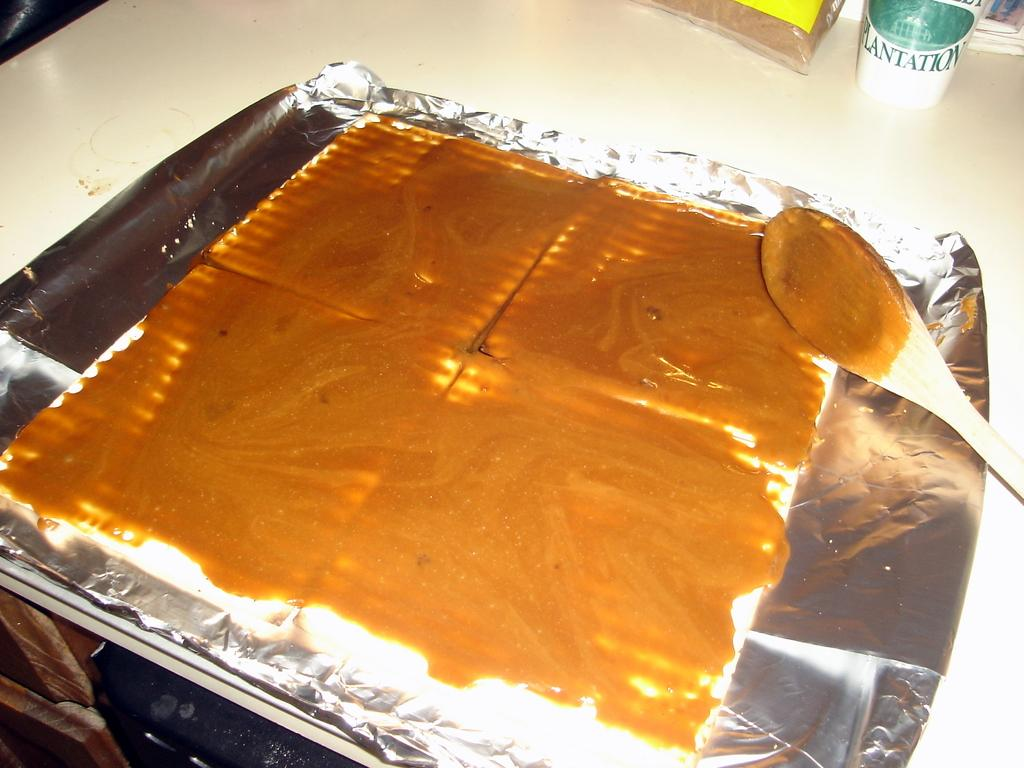What is the food placed on in the image? The food is placed on a silver color aluminum foil in the image. What else can be seen in the image besides the food? There is a packet visible in the image. Can you describe the color and pattern of the object in the image? The object has a white and green color pattern. What is the color of the surface on which the objects are placed? The objects are on a cream color surface. Where is the frog sitting in the image? There is no frog present in the image. What unit of measurement is used to describe the size of the objects in the image? The provided facts do not mention any unit of measurement for the objects in the image. 